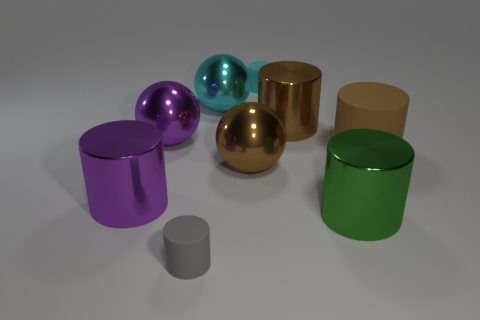Is the tiny cylinder in front of the big cyan sphere made of the same material as the big cylinder behind the big brown rubber thing?
Ensure brevity in your answer.  No. What is the material of the brown sphere?
Provide a short and direct response. Metal. What number of large brown metal objects have the same shape as the big cyan thing?
Your answer should be compact. 1. There is a sphere that is the same color as the large matte cylinder; what material is it?
Give a very brief answer. Metal. Are there any other things that are the same shape as the gray rubber thing?
Give a very brief answer. Yes. There is a metallic object on the right side of the big cylinder behind the rubber cylinder that is on the right side of the big brown shiny cylinder; what is its color?
Keep it short and to the point. Green. What number of tiny objects are brown metallic objects or cylinders?
Provide a short and direct response. 2. Is the number of cyan metal objects that are behind the small gray matte object the same as the number of big cyan metal spheres?
Offer a terse response. Yes. Are there any big shiny balls in front of the large rubber thing?
Ensure brevity in your answer.  Yes. How many shiny things are either large purple balls or brown things?
Offer a very short reply. 3. 